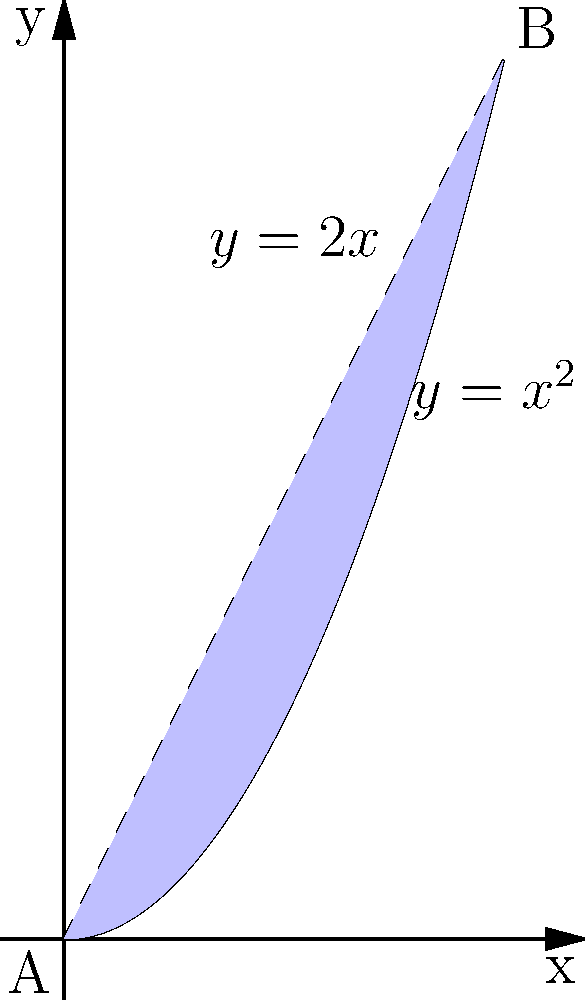Find the area of the shaded region bounded by the functions $y=x^2$ and $y=2x$ from $x=0$ to $x=2$. To find the area between two intersecting functions, we need to follow these steps:

1) First, identify the intersection points. We can see from the graph that the functions intersect at $(0,0)$ and $(2,4)$.

2) Set up the integral. The area is given by:

   $$A = \int_{0}^{2} (2x - x^2) dx$$

   Here, we subtract the lower function $(x^2)$ from the upper function $(2x)$.

3) Evaluate the integral:

   $$A = \int_{0}^{2} (2x - x^2) dx = [x^2 - \frac{x^3}{3}]_{0}^{2}$$

4) Calculate the result:

   $$A = (2^2 - \frac{2^3}{3}) - (0^2 - \frac{0^3}{3}) = (4 - \frac{8}{3}) - 0 = \frac{4}{3}$$

Therefore, the area of the shaded region is $\frac{4}{3}$ square units.
Answer: $\frac{4}{3}$ square units 